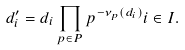<formula> <loc_0><loc_0><loc_500><loc_500>d _ { i } ^ { \prime } = d _ { i } \prod _ { p \in P } p ^ { - \nu _ { p } ( d _ { i } ) } i \in I .</formula> 